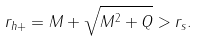Convert formula to latex. <formula><loc_0><loc_0><loc_500><loc_500>r _ { h + } = M + \sqrt { M ^ { 2 } + Q } > r _ { s } .</formula> 